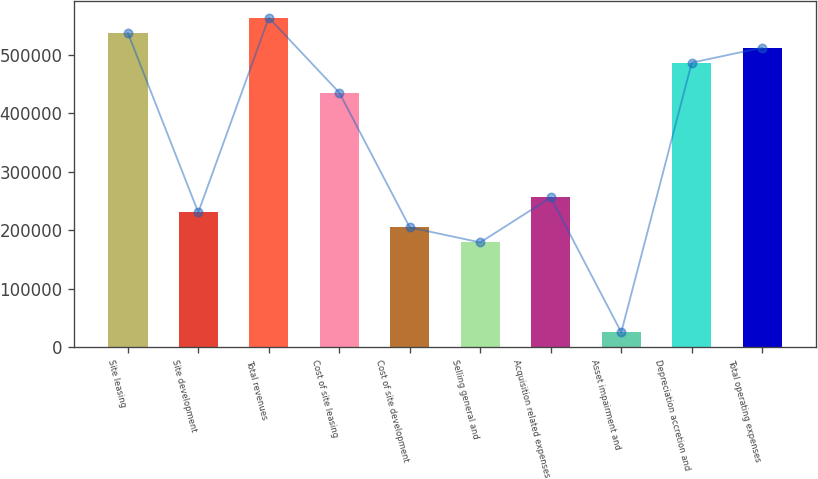Convert chart. <chart><loc_0><loc_0><loc_500><loc_500><bar_chart><fcel>Site leasing<fcel>Site development<fcel>Total revenues<fcel>Cost of site leasing<fcel>Cost of site development<fcel>Selling general and<fcel>Acquisition related expenses<fcel>Asset impairment and<fcel>Depreciation accretion and<fcel>Total operating expenses<nl><fcel>537328<fcel>230331<fcel>562911<fcel>434996<fcel>204748<fcel>179165<fcel>255914<fcel>25666.1<fcel>486162<fcel>511745<nl></chart> 